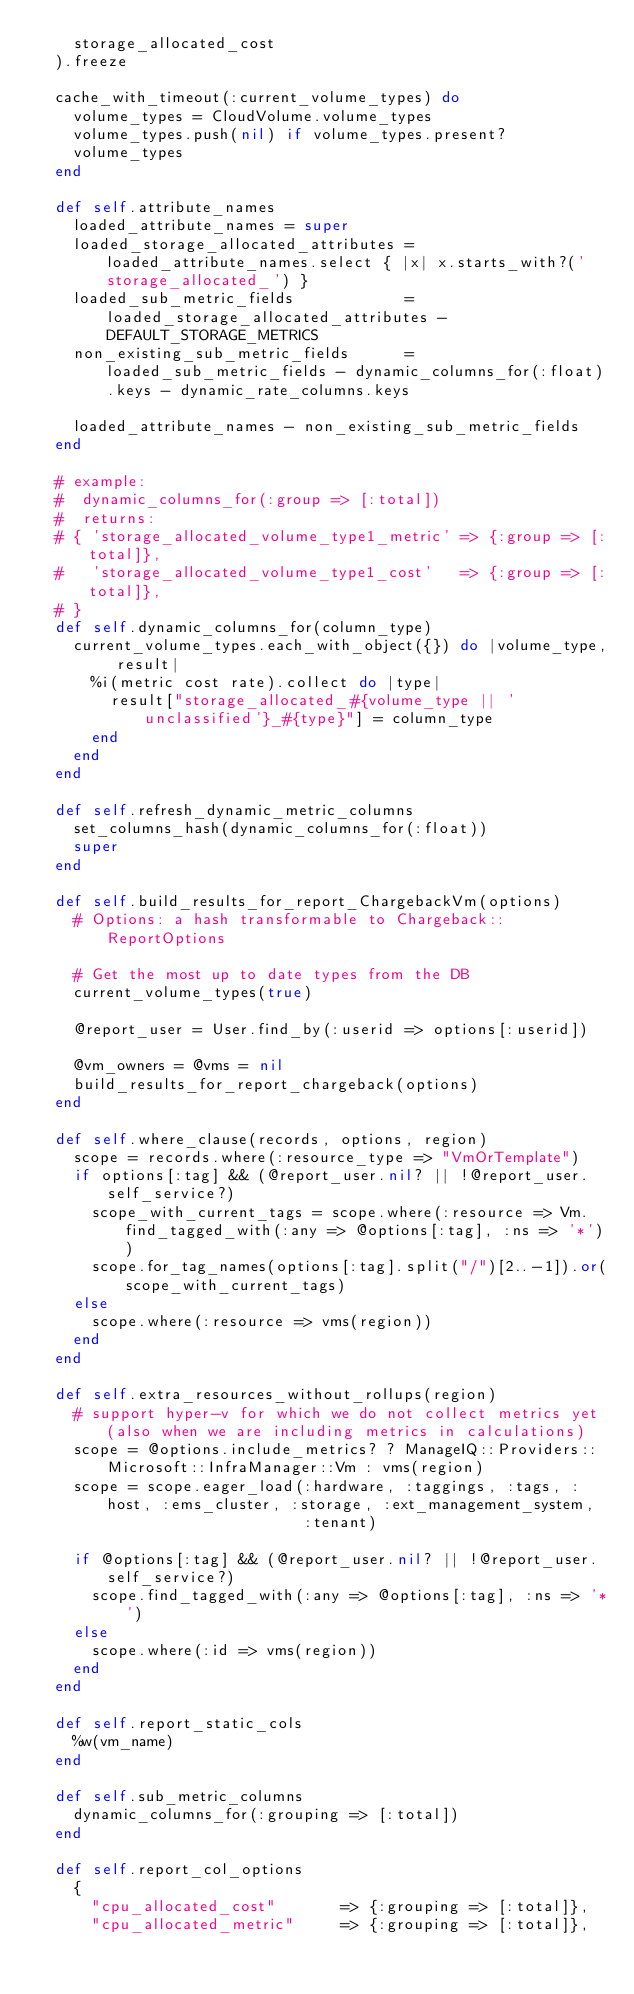Convert code to text. <code><loc_0><loc_0><loc_500><loc_500><_Ruby_>    storage_allocated_cost
  ).freeze

  cache_with_timeout(:current_volume_types) do
    volume_types = CloudVolume.volume_types
    volume_types.push(nil) if volume_types.present?
    volume_types
  end

  def self.attribute_names
    loaded_attribute_names = super
    loaded_storage_allocated_attributes = loaded_attribute_names.select { |x| x.starts_with?('storage_allocated_') }
    loaded_sub_metric_fields            = loaded_storage_allocated_attributes - DEFAULT_STORAGE_METRICS
    non_existing_sub_metric_fields      = loaded_sub_metric_fields - dynamic_columns_for(:float).keys - dynamic_rate_columns.keys

    loaded_attribute_names - non_existing_sub_metric_fields
  end

  # example:
  #  dynamic_columns_for(:group => [:total])
  #  returns:
  # { 'storage_allocated_volume_type1_metric' => {:group => [:total]},
  #   'storage_allocated_volume_type1_cost'   => {:group => [:total]},
  # }
  def self.dynamic_columns_for(column_type)
    current_volume_types.each_with_object({}) do |volume_type, result|
      %i(metric cost rate).collect do |type|
        result["storage_allocated_#{volume_type || 'unclassified'}_#{type}"] = column_type
      end
    end
  end

  def self.refresh_dynamic_metric_columns
    set_columns_hash(dynamic_columns_for(:float))
    super
  end

  def self.build_results_for_report_ChargebackVm(options)
    # Options: a hash transformable to Chargeback::ReportOptions

    # Get the most up to date types from the DB
    current_volume_types(true)

    @report_user = User.find_by(:userid => options[:userid])

    @vm_owners = @vms = nil
    build_results_for_report_chargeback(options)
  end

  def self.where_clause(records, options, region)
    scope = records.where(:resource_type => "VmOrTemplate")
    if options[:tag] && (@report_user.nil? || !@report_user.self_service?)
      scope_with_current_tags = scope.where(:resource => Vm.find_tagged_with(:any => @options[:tag], :ns => '*'))
      scope.for_tag_names(options[:tag].split("/")[2..-1]).or(scope_with_current_tags)
    else
      scope.where(:resource => vms(region))
    end
  end

  def self.extra_resources_without_rollups(region)
    # support hyper-v for which we do not collect metrics yet (also when we are including metrics in calculations)
    scope = @options.include_metrics? ? ManageIQ::Providers::Microsoft::InfraManager::Vm : vms(region)
    scope = scope.eager_load(:hardware, :taggings, :tags, :host, :ems_cluster, :storage, :ext_management_system,
                             :tenant)

    if @options[:tag] && (@report_user.nil? || !@report_user.self_service?)
      scope.find_tagged_with(:any => @options[:tag], :ns => '*')
    else
      scope.where(:id => vms(region))
    end
  end

  def self.report_static_cols
    %w(vm_name)
  end

  def self.sub_metric_columns
    dynamic_columns_for(:grouping => [:total])
  end

  def self.report_col_options
    {
      "cpu_allocated_cost"       => {:grouping => [:total]},
      "cpu_allocated_metric"     => {:grouping => [:total]},</code> 